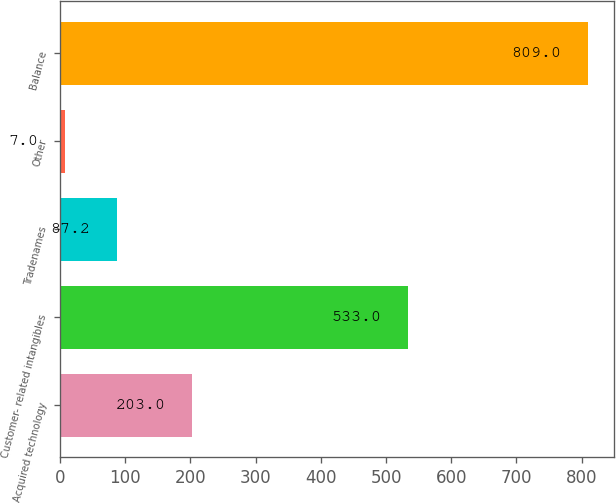<chart> <loc_0><loc_0><loc_500><loc_500><bar_chart><fcel>Acquired technology<fcel>Customer- related intangibles<fcel>Tradenames<fcel>Other<fcel>Balance<nl><fcel>203<fcel>533<fcel>87.2<fcel>7<fcel>809<nl></chart> 